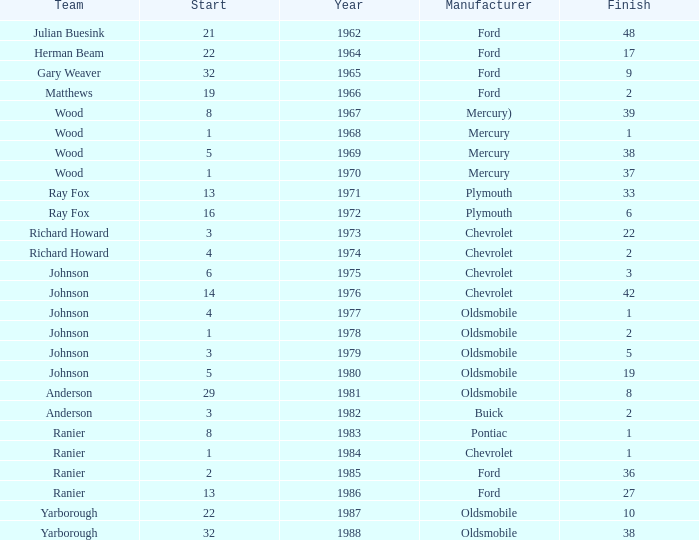Who was the maufacturer of the vehicle during the race where Cale Yarborough started at 19 and finished earlier than 42? Ford. 